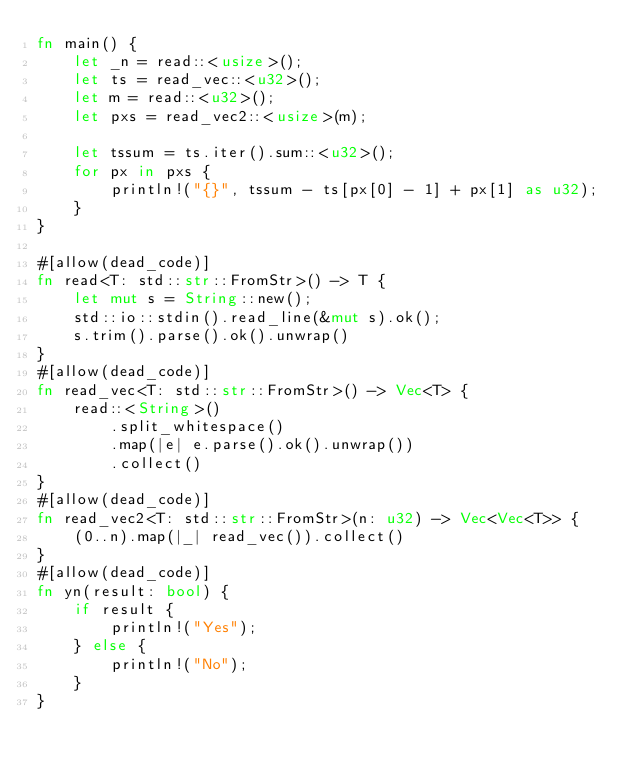Convert code to text. <code><loc_0><loc_0><loc_500><loc_500><_Rust_>fn main() {
    let _n = read::<usize>();
    let ts = read_vec::<u32>();
    let m = read::<u32>();
    let pxs = read_vec2::<usize>(m);

    let tssum = ts.iter().sum::<u32>();
    for px in pxs {
        println!("{}", tssum - ts[px[0] - 1] + px[1] as u32);
    }
}

#[allow(dead_code)]
fn read<T: std::str::FromStr>() -> T {
    let mut s = String::new();
    std::io::stdin().read_line(&mut s).ok();
    s.trim().parse().ok().unwrap()
}
#[allow(dead_code)]
fn read_vec<T: std::str::FromStr>() -> Vec<T> {
    read::<String>()
        .split_whitespace()
        .map(|e| e.parse().ok().unwrap())
        .collect()
}
#[allow(dead_code)]
fn read_vec2<T: std::str::FromStr>(n: u32) -> Vec<Vec<T>> {
    (0..n).map(|_| read_vec()).collect()
}
#[allow(dead_code)]
fn yn(result: bool) {
    if result {
        println!("Yes");
    } else {
        println!("No");
    }
}
</code> 